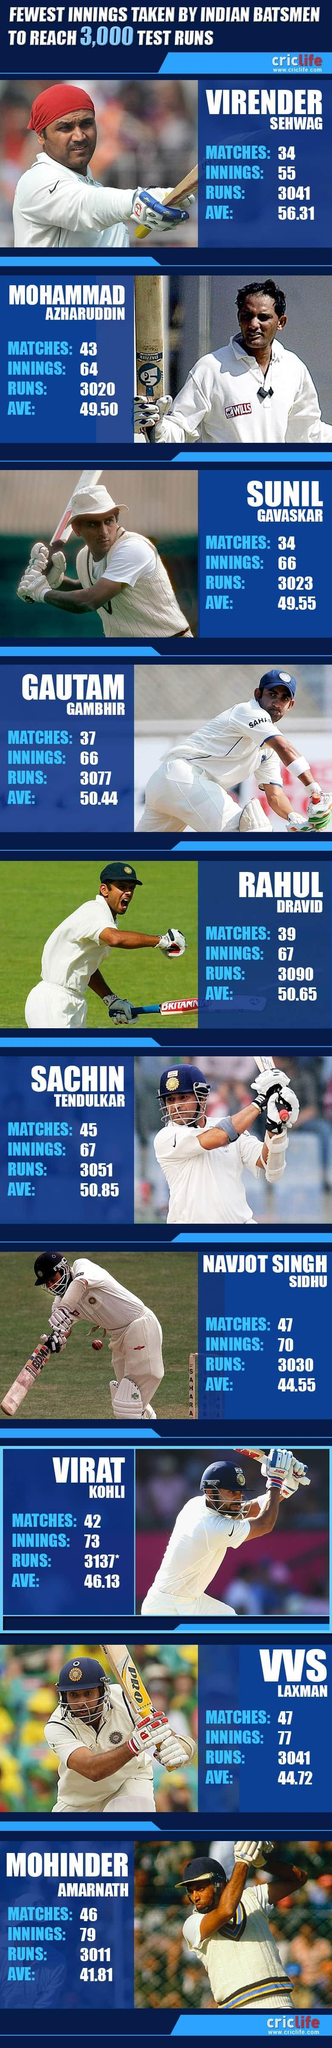What was the second highest batting average?
Answer the question with a short phrase. 50.85 What was the highest number of runs taken ? 3137 